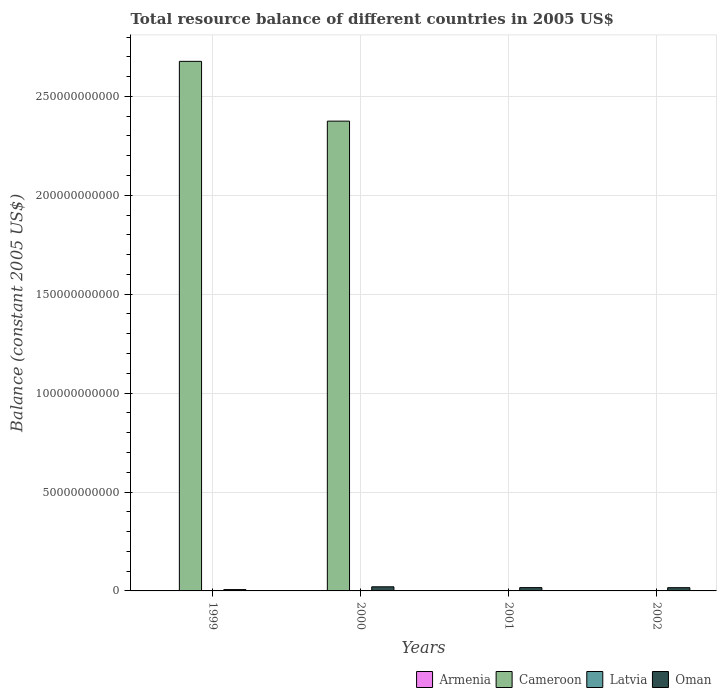How many different coloured bars are there?
Your answer should be very brief. 2. What is the label of the 1st group of bars from the left?
Provide a succinct answer. 1999. What is the total resource balance in Oman in 2001?
Offer a very short reply. 1.67e+09. Across all years, what is the maximum total resource balance in Cameroon?
Your answer should be very brief. 2.68e+11. Across all years, what is the minimum total resource balance in Oman?
Ensure brevity in your answer.  6.72e+08. In which year was the total resource balance in Oman maximum?
Your answer should be compact. 2000. What is the difference between the total resource balance in Cameroon in 1999 and that in 2000?
Your response must be concise. 3.02e+1. What is the difference between the total resource balance in Armenia in 2001 and the total resource balance in Oman in 1999?
Keep it short and to the point. -6.72e+08. What is the average total resource balance in Cameroon per year?
Your response must be concise. 1.26e+11. In the year 1999, what is the difference between the total resource balance in Oman and total resource balance in Cameroon?
Your answer should be very brief. -2.67e+11. What is the ratio of the total resource balance in Oman in 1999 to that in 2001?
Provide a succinct answer. 0.4. Is the total resource balance in Oman in 2001 less than that in 2002?
Make the answer very short. No. What is the difference between the highest and the second highest total resource balance in Oman?
Your answer should be very brief. 4.11e+08. What is the difference between the highest and the lowest total resource balance in Oman?
Your response must be concise. 1.41e+09. Is it the case that in every year, the sum of the total resource balance in Oman and total resource balance in Latvia is greater than the total resource balance in Cameroon?
Your answer should be compact. No. Are all the bars in the graph horizontal?
Provide a succinct answer. No. How many years are there in the graph?
Make the answer very short. 4. What is the difference between two consecutive major ticks on the Y-axis?
Your response must be concise. 5.00e+1. Are the values on the major ticks of Y-axis written in scientific E-notation?
Offer a very short reply. No. Where does the legend appear in the graph?
Provide a short and direct response. Bottom right. What is the title of the graph?
Give a very brief answer. Total resource balance of different countries in 2005 US$. Does "Tonga" appear as one of the legend labels in the graph?
Give a very brief answer. No. What is the label or title of the Y-axis?
Keep it short and to the point. Balance (constant 2005 US$). What is the Balance (constant 2005 US$) in Armenia in 1999?
Your answer should be compact. 0. What is the Balance (constant 2005 US$) of Cameroon in 1999?
Give a very brief answer. 2.68e+11. What is the Balance (constant 2005 US$) of Latvia in 1999?
Ensure brevity in your answer.  0. What is the Balance (constant 2005 US$) in Oman in 1999?
Keep it short and to the point. 6.72e+08. What is the Balance (constant 2005 US$) in Armenia in 2000?
Provide a short and direct response. 0. What is the Balance (constant 2005 US$) of Cameroon in 2000?
Your answer should be compact. 2.37e+11. What is the Balance (constant 2005 US$) in Latvia in 2000?
Make the answer very short. 0. What is the Balance (constant 2005 US$) in Oman in 2000?
Your answer should be compact. 2.08e+09. What is the Balance (constant 2005 US$) in Oman in 2001?
Your answer should be compact. 1.67e+09. What is the Balance (constant 2005 US$) of Armenia in 2002?
Your response must be concise. 0. What is the Balance (constant 2005 US$) of Cameroon in 2002?
Offer a terse response. 0. What is the Balance (constant 2005 US$) of Oman in 2002?
Provide a succinct answer. 1.64e+09. Across all years, what is the maximum Balance (constant 2005 US$) of Cameroon?
Offer a terse response. 2.68e+11. Across all years, what is the maximum Balance (constant 2005 US$) in Oman?
Provide a succinct answer. 2.08e+09. Across all years, what is the minimum Balance (constant 2005 US$) of Oman?
Give a very brief answer. 6.72e+08. What is the total Balance (constant 2005 US$) of Armenia in the graph?
Your answer should be compact. 0. What is the total Balance (constant 2005 US$) in Cameroon in the graph?
Offer a very short reply. 5.05e+11. What is the total Balance (constant 2005 US$) in Oman in the graph?
Your answer should be compact. 6.07e+09. What is the difference between the Balance (constant 2005 US$) in Cameroon in 1999 and that in 2000?
Keep it short and to the point. 3.02e+1. What is the difference between the Balance (constant 2005 US$) of Oman in 1999 and that in 2000?
Your response must be concise. -1.41e+09. What is the difference between the Balance (constant 2005 US$) in Oman in 1999 and that in 2001?
Give a very brief answer. -1.00e+09. What is the difference between the Balance (constant 2005 US$) of Oman in 1999 and that in 2002?
Provide a succinct answer. -9.69e+08. What is the difference between the Balance (constant 2005 US$) in Oman in 2000 and that in 2001?
Ensure brevity in your answer.  4.11e+08. What is the difference between the Balance (constant 2005 US$) in Oman in 2000 and that in 2002?
Ensure brevity in your answer.  4.43e+08. What is the difference between the Balance (constant 2005 US$) in Oman in 2001 and that in 2002?
Provide a succinct answer. 3.20e+07. What is the difference between the Balance (constant 2005 US$) of Cameroon in 1999 and the Balance (constant 2005 US$) of Oman in 2000?
Keep it short and to the point. 2.66e+11. What is the difference between the Balance (constant 2005 US$) of Cameroon in 1999 and the Balance (constant 2005 US$) of Oman in 2001?
Make the answer very short. 2.66e+11. What is the difference between the Balance (constant 2005 US$) of Cameroon in 1999 and the Balance (constant 2005 US$) of Oman in 2002?
Your answer should be compact. 2.66e+11. What is the difference between the Balance (constant 2005 US$) in Cameroon in 2000 and the Balance (constant 2005 US$) in Oman in 2001?
Your answer should be very brief. 2.36e+11. What is the difference between the Balance (constant 2005 US$) of Cameroon in 2000 and the Balance (constant 2005 US$) of Oman in 2002?
Ensure brevity in your answer.  2.36e+11. What is the average Balance (constant 2005 US$) in Armenia per year?
Your answer should be compact. 0. What is the average Balance (constant 2005 US$) of Cameroon per year?
Offer a very short reply. 1.26e+11. What is the average Balance (constant 2005 US$) of Oman per year?
Your answer should be compact. 1.52e+09. In the year 1999, what is the difference between the Balance (constant 2005 US$) in Cameroon and Balance (constant 2005 US$) in Oman?
Offer a very short reply. 2.67e+11. In the year 2000, what is the difference between the Balance (constant 2005 US$) of Cameroon and Balance (constant 2005 US$) of Oman?
Your answer should be very brief. 2.35e+11. What is the ratio of the Balance (constant 2005 US$) in Cameroon in 1999 to that in 2000?
Keep it short and to the point. 1.13. What is the ratio of the Balance (constant 2005 US$) of Oman in 1999 to that in 2000?
Your response must be concise. 0.32. What is the ratio of the Balance (constant 2005 US$) in Oman in 1999 to that in 2001?
Offer a very short reply. 0.4. What is the ratio of the Balance (constant 2005 US$) in Oman in 1999 to that in 2002?
Ensure brevity in your answer.  0.41. What is the ratio of the Balance (constant 2005 US$) in Oman in 2000 to that in 2001?
Your answer should be compact. 1.25. What is the ratio of the Balance (constant 2005 US$) in Oman in 2000 to that in 2002?
Provide a succinct answer. 1.27. What is the ratio of the Balance (constant 2005 US$) in Oman in 2001 to that in 2002?
Provide a short and direct response. 1.02. What is the difference between the highest and the second highest Balance (constant 2005 US$) in Oman?
Give a very brief answer. 4.11e+08. What is the difference between the highest and the lowest Balance (constant 2005 US$) in Cameroon?
Your response must be concise. 2.68e+11. What is the difference between the highest and the lowest Balance (constant 2005 US$) of Oman?
Offer a very short reply. 1.41e+09. 